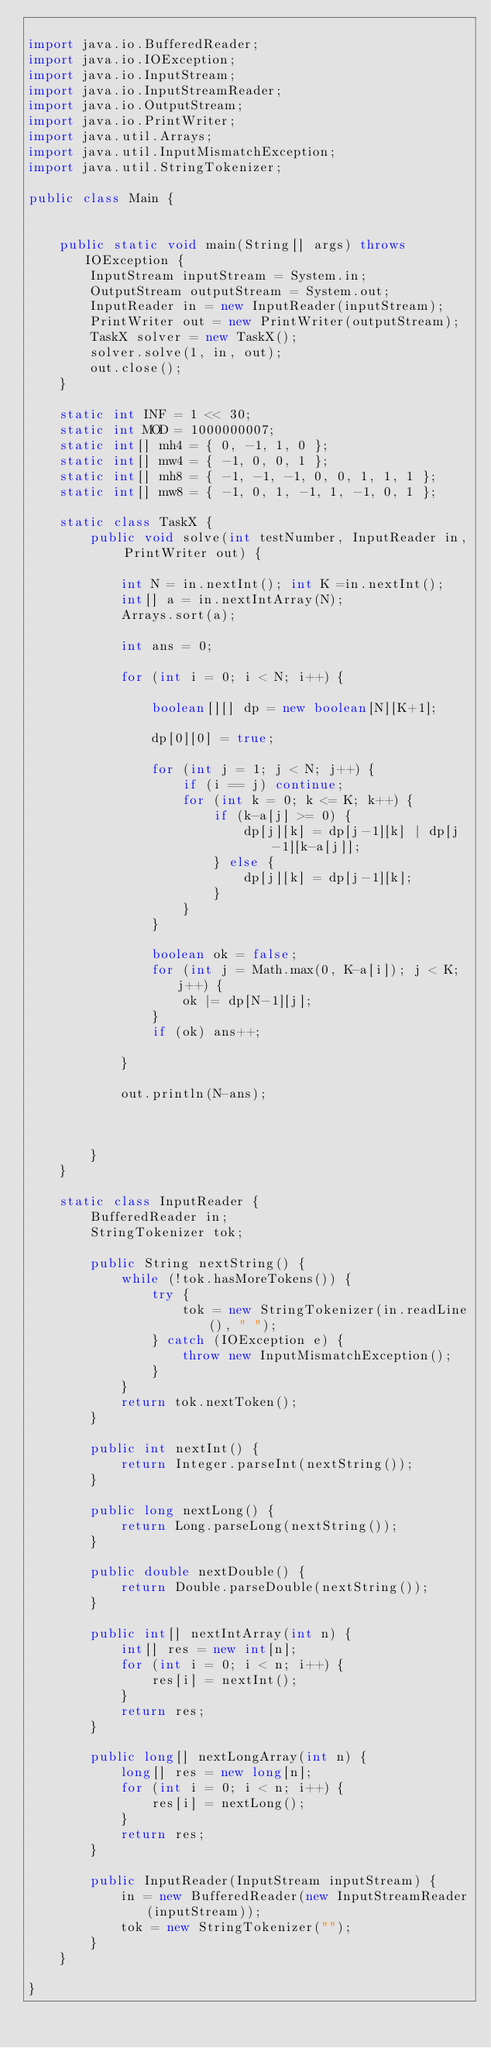Convert code to text. <code><loc_0><loc_0><loc_500><loc_500><_Java_>
import java.io.BufferedReader;
import java.io.IOException;
import java.io.InputStream;
import java.io.InputStreamReader;
import java.io.OutputStream;
import java.io.PrintWriter;
import java.util.Arrays;
import java.util.InputMismatchException;
import java.util.StringTokenizer;

public class Main {


	public static void main(String[] args) throws IOException {
		InputStream inputStream = System.in;
		OutputStream outputStream = System.out;
		InputReader in = new InputReader(inputStream);
		PrintWriter out = new PrintWriter(outputStream);
		TaskX solver = new TaskX();
		solver.solve(1, in, out);
		out.close();
	}

	static int INF = 1 << 30;
	static int MOD = 1000000007;
	static int[] mh4 = { 0, -1, 1, 0 };
	static int[] mw4 = { -1, 0, 0, 1 };
	static int[] mh8 = { -1, -1, -1, 0, 0, 1, 1, 1 };
	static int[] mw8 = { -1, 0, 1, -1, 1, -1, 0, 1 };

	static class TaskX {
		public void solve(int testNumber, InputReader in, PrintWriter out) {

			int N = in.nextInt(); int K =in.nextInt();
			int[] a = in.nextIntArray(N);
			Arrays.sort(a);

			int ans = 0;

			for (int i = 0; i < N; i++) {

				boolean[][] dp = new boolean[N][K+1];

				dp[0][0] = true;

				for (int j = 1; j < N; j++) {
					if (i == j) continue;
					for (int k = 0; k <= K; k++) {
						if (k-a[j] >= 0) {
							dp[j][k] = dp[j-1][k] | dp[j-1][k-a[j]];
						} else {
							dp[j][k] = dp[j-1][k];
						}
					}
				}

				boolean ok = false;
				for (int j = Math.max(0, K-a[i]); j < K; j++) {
					ok |= dp[N-1][j];
				}
				if (ok) ans++;

			}

			out.println(N-ans);



		}
	}

	static class InputReader {
		BufferedReader in;
		StringTokenizer tok;

		public String nextString() {
			while (!tok.hasMoreTokens()) {
				try {
					tok = new StringTokenizer(in.readLine(), " ");
				} catch (IOException e) {
					throw new InputMismatchException();
				}
			}
			return tok.nextToken();
		}

		public int nextInt() {
			return Integer.parseInt(nextString());
		}

		public long nextLong() {
			return Long.parseLong(nextString());
		}

		public double nextDouble() {
			return Double.parseDouble(nextString());
		}

		public int[] nextIntArray(int n) {
			int[] res = new int[n];
			for (int i = 0; i < n; i++) {
				res[i] = nextInt();
			}
			return res;
		}

		public long[] nextLongArray(int n) {
			long[] res = new long[n];
			for (int i = 0; i < n; i++) {
				res[i] = nextLong();
			}
			return res;
		}

		public InputReader(InputStream inputStream) {
			in = new BufferedReader(new InputStreamReader(inputStream));
			tok = new StringTokenizer("");
		}
	}

}
</code> 